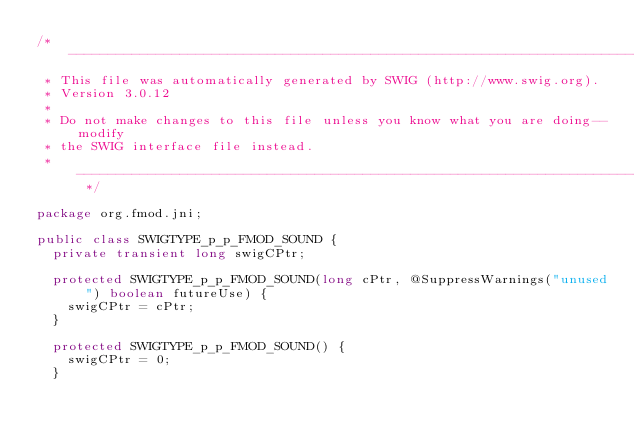Convert code to text. <code><loc_0><loc_0><loc_500><loc_500><_Java_>/* ----------------------------------------------------------------------------
 * This file was automatically generated by SWIG (http://www.swig.org).
 * Version 3.0.12
 *
 * Do not make changes to this file unless you know what you are doing--modify
 * the SWIG interface file instead.
 * ----------------------------------------------------------------------------- */

package org.fmod.jni;

public class SWIGTYPE_p_p_FMOD_SOUND {
  private transient long swigCPtr;

  protected SWIGTYPE_p_p_FMOD_SOUND(long cPtr, @SuppressWarnings("unused") boolean futureUse) {
    swigCPtr = cPtr;
  }

  protected SWIGTYPE_p_p_FMOD_SOUND() {
    swigCPtr = 0;
  }
</code> 